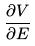Convert formula to latex. <formula><loc_0><loc_0><loc_500><loc_500>\frac { \partial V } { \partial E }</formula> 